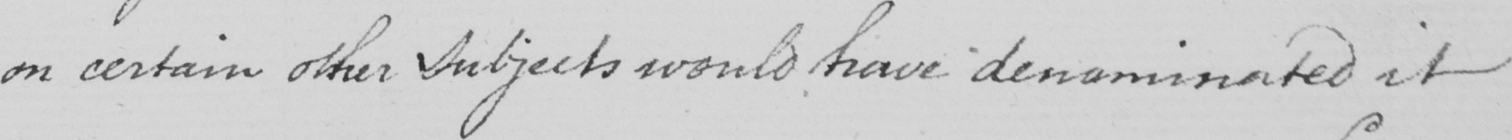What is written in this line of handwriting? on certain other Subjects would have denominated it 